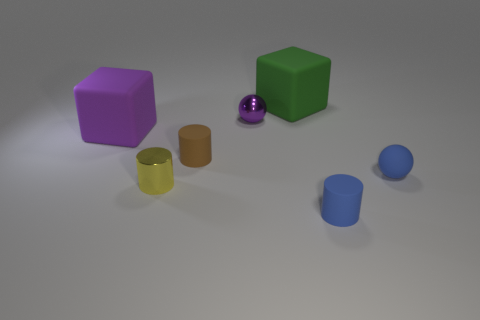Subtract all tiny brown matte cylinders. How many cylinders are left? 2 Subtract all blocks. How many objects are left? 5 Add 1 big red shiny objects. How many objects exist? 8 Subtract all brown cylinders. How many cylinders are left? 2 Subtract all green cylinders. Subtract all yellow blocks. How many cylinders are left? 3 Subtract all cubes. Subtract all green cubes. How many objects are left? 4 Add 6 large purple matte blocks. How many large purple matte blocks are left? 7 Add 4 big green rubber objects. How many big green rubber objects exist? 5 Subtract 0 red spheres. How many objects are left? 7 